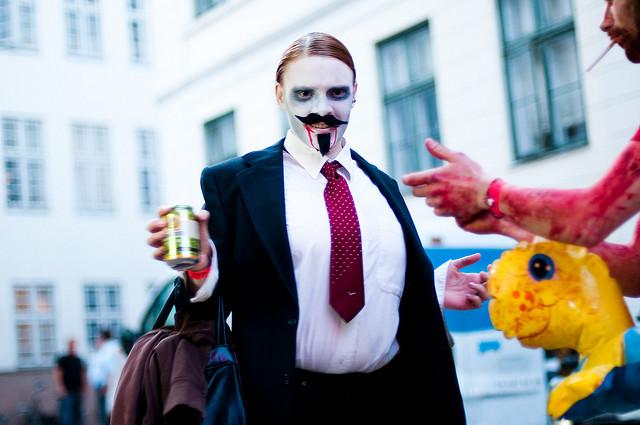What is the man looking at?
Concise answer only. Camera. Is this a clown?
Short answer required. No. Is this a guy or a girl?
Give a very brief answer. Girl. 